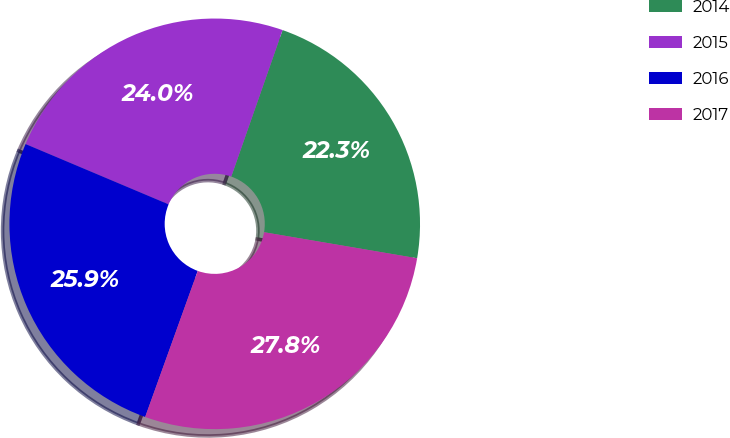<chart> <loc_0><loc_0><loc_500><loc_500><pie_chart><fcel>2014<fcel>2015<fcel>2016<fcel>2017<nl><fcel>22.32%<fcel>24.01%<fcel>25.85%<fcel>27.82%<nl></chart> 